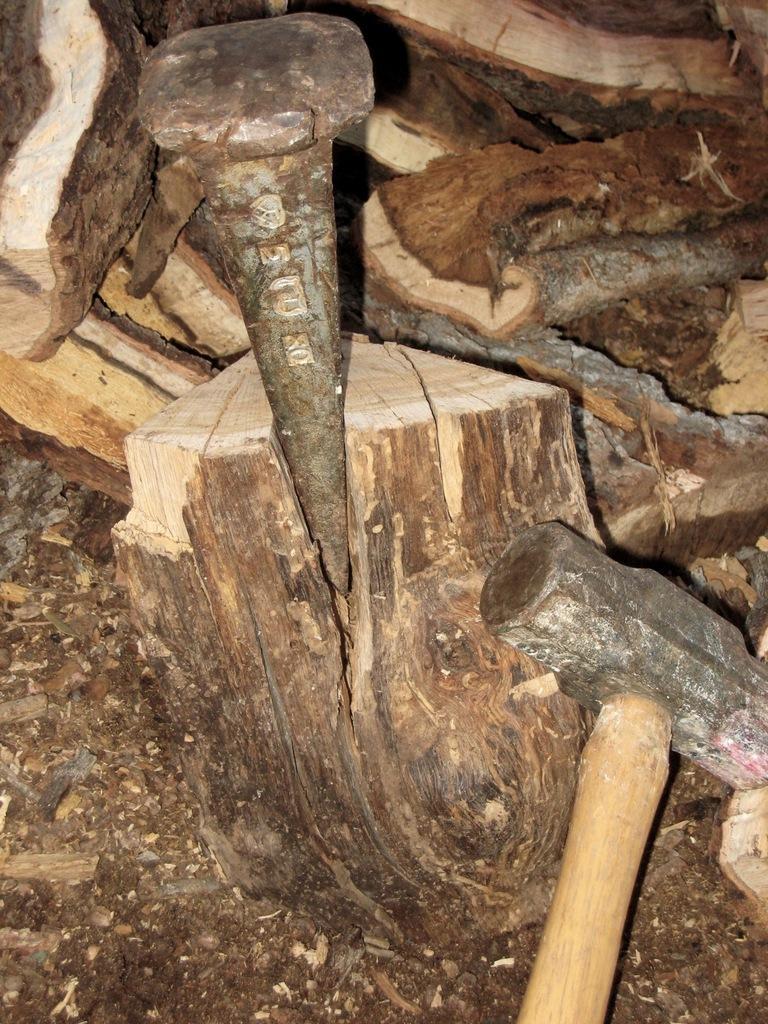How would you summarize this image in a sentence or two? In this image there is the wood, there is a hammer truncated towards the bottom of the image, there is a nail. 